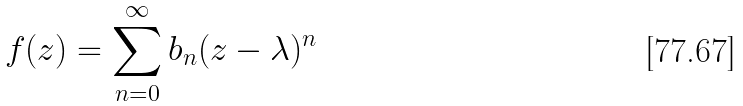Convert formula to latex. <formula><loc_0><loc_0><loc_500><loc_500>f ( z ) = \sum _ { n = 0 } ^ { \infty } b _ { n } ( z - \lambda ) ^ { n }</formula> 